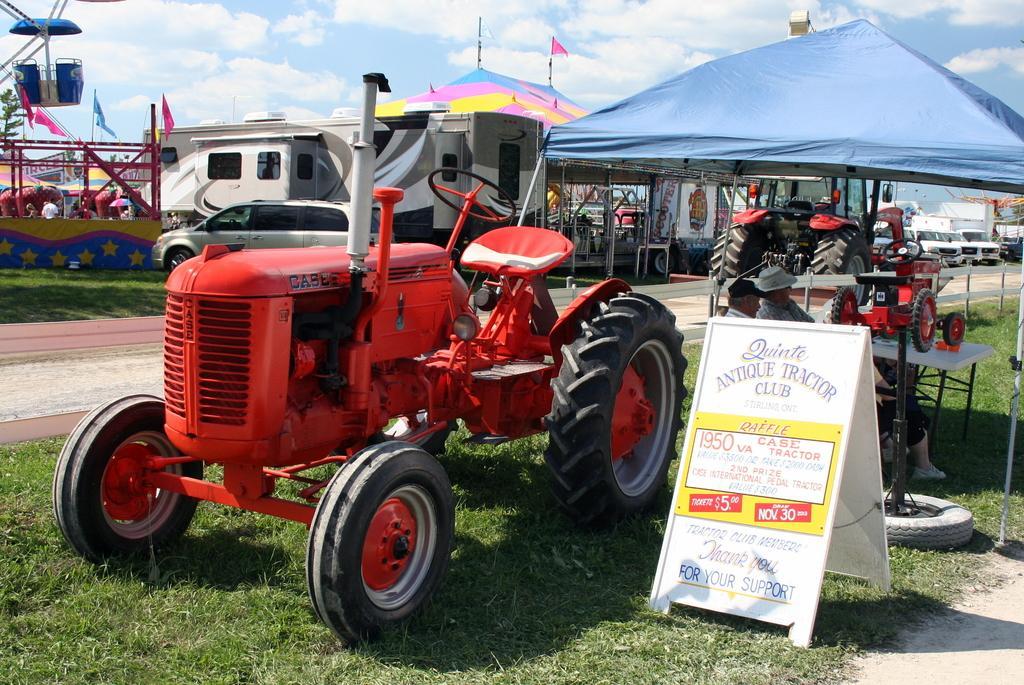How would you summarize this image in a sentence or two? In this image I can feel grass, shadows, a board, few red colour tractors, few other vehicles and here on this board I can see something is written. I can also see few people are sitting over here and in background I can see number of flags, clouds and the sky. 